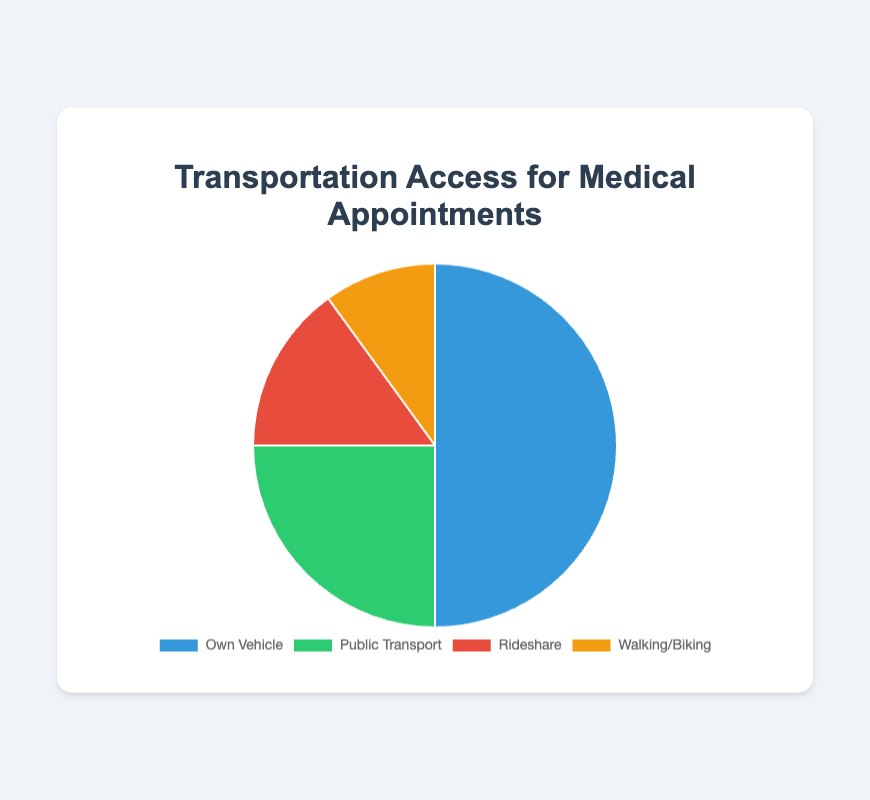Which mode of transportation has the highest percentage? The figure shows that "Own Vehicle" has the largest section of the pie chart, taking up 50% of the whole.
Answer: Own Vehicle Which two modes of transportation combined have the same percentage as "Own Vehicle"? "Public Transport" (25%) plus "Rideshare" (15%) plus "Walking/Biking" (10%) equals 25 + 15 + 10 = 50%, which is the same as "Own Vehicle".
Answer: Public Transport and Rideshare and Walking/Biking What is the percentage difference between "Own Vehicle" and "Public Transport"? The percentage for "Own Vehicle" is 50%, and the percentage for "Public Transport" is 25%. The difference is 50 - 25 = 25%.
Answer: 25% Are there more people using "Public Transport" or "Rideshare"? The figure indicates that "Public Transport" accounts for 25% while "Rideshare" accounts for 15%. Since 25% is greater than 15%, more people use Public Transport.
Answer: Public Transport Which mode of transportation has the least usage? The smallest portion of the pie chart represents "Walking/Biking", which accounts for 10%.
Answer: Walking/Biking How much more popular is "Own Vehicle" compared to "Walking/Biking"? "Own Vehicle" has 50% usage, while "Walking/Biking" has 10% usage. The difference is 50 - 10 = 40%.
Answer: 40% If 1000 people were surveyed, how many would use "Rideshare"? 15% of people use "Rideshare". Therefore, 15% of 1000 equals 0.15 * 1000 = 150 people.
Answer: 150 What is the total percentage for "Public Transport" and "Walking/Biking"? "Public Transport" is 25%, and "Walking/Biking" is 10%. The total percentage is 25 + 10 = 35%.
Answer: 35% What color represents "Rideshare" on the chart? The visual shows four colors, with "Rideshare" being represented by the red section of the pie chart.
Answer: Red 